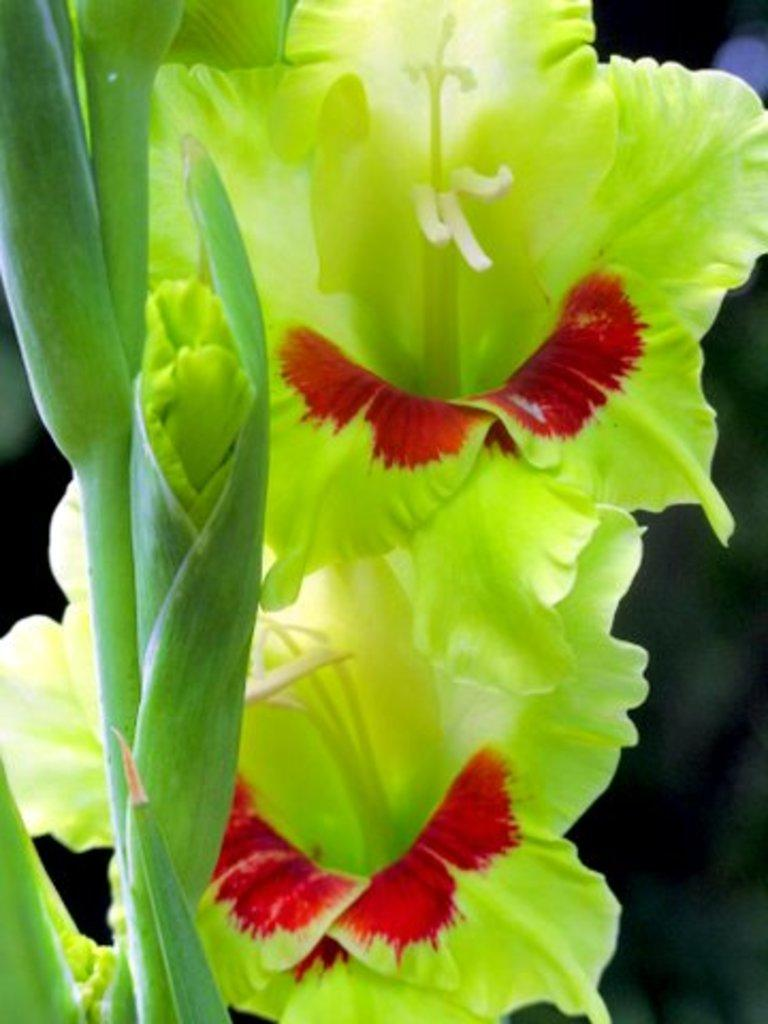What type of plant is visible in the image? There is a plant in the image, and it has flowers and buds. What stage of growth are the flowers in the image? The flowers are visible on the plant, indicating that they are in bloom. What can be observed about the background of the image? The background of the image is blurred. What type of fruit is hanging from the tub in the image? There is no tub or fruit present in the image; it features a plant with flowers and buds. 